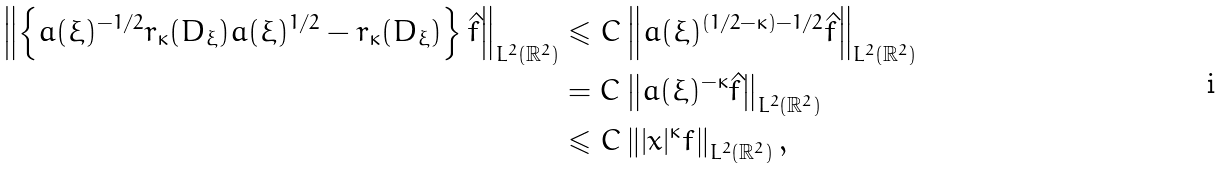<formula> <loc_0><loc_0><loc_500><loc_500>\left \| \left \{ a ( \xi ) ^ { - 1 / 2 } r _ { \kappa } ( D _ { \xi } ) a ( \xi ) ^ { 1 / 2 } - r _ { \kappa } ( D _ { \xi } ) \right \} \hat { f } \right \| _ { L ^ { 2 } ( \mathbb { R } ^ { 2 } ) } & \leqslant C \left \| a ( \xi ) ^ { ( 1 / 2 - \kappa ) - 1 / 2 } \hat { f } \right \| _ { L ^ { 2 } ( \mathbb { R } ^ { 2 } ) } \\ & = C \left \| a ( \xi ) ^ { - \kappa } \hat { f } \right \| _ { L ^ { 2 } ( \mathbb { R } ^ { 2 } ) } \\ & \leqslant C \left \| | { x } | ^ { \kappa } { f } \right \| _ { L ^ { 2 } ( \mathbb { R } ^ { 2 } ) } ,</formula> 